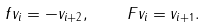<formula> <loc_0><loc_0><loc_500><loc_500>f v _ { i } = - v _ { i + 2 } , \quad F v _ { i } = v _ { i + 1 } .</formula> 